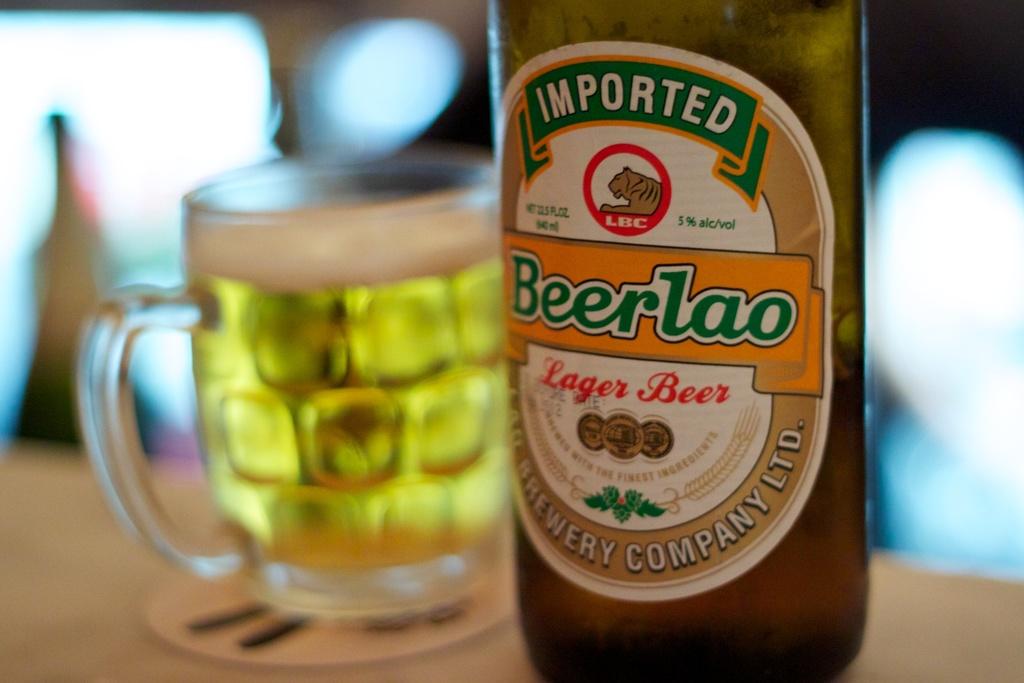What kind of beer is in the bottle?
Offer a terse response. Lager. Is this beer imported or not?
Your response must be concise. Yes. 